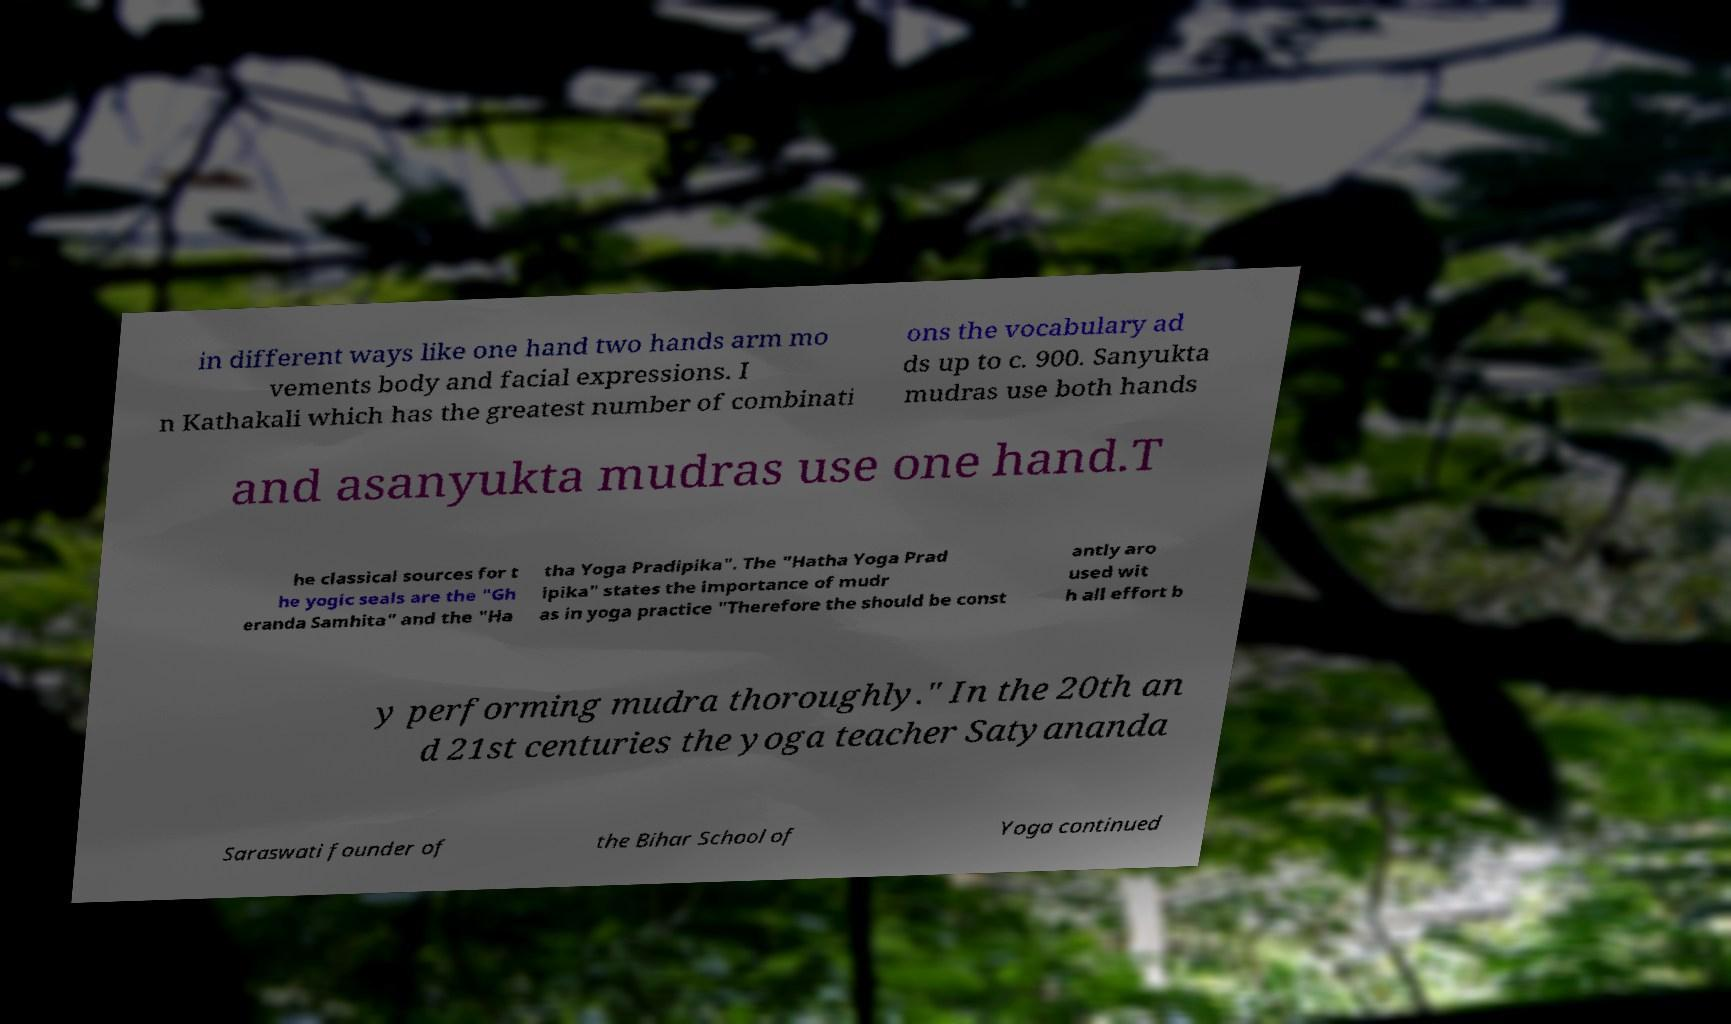Can you accurately transcribe the text from the provided image for me? in different ways like one hand two hands arm mo vements body and facial expressions. I n Kathakali which has the greatest number of combinati ons the vocabulary ad ds up to c. 900. Sanyukta mudras use both hands and asanyukta mudras use one hand.T he classical sources for t he yogic seals are the "Gh eranda Samhita" and the "Ha tha Yoga Pradipika". The "Hatha Yoga Prad ipika" states the importance of mudr as in yoga practice "Therefore the should be const antly aro used wit h all effort b y performing mudra thoroughly." In the 20th an d 21st centuries the yoga teacher Satyananda Saraswati founder of the Bihar School of Yoga continued 